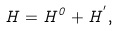Convert formula to latex. <formula><loc_0><loc_0><loc_500><loc_500>H = H ^ { 0 } + H ^ { ^ { \prime } } ,</formula> 